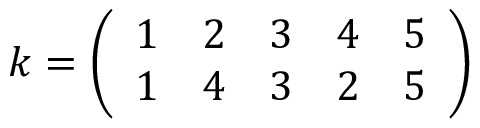Convert formula to latex. <formula><loc_0><loc_0><loc_500><loc_500>k = { \left ( \begin{array} { l l l l l } { 1 } & { 2 } & { 3 } & { 4 } & { 5 } \\ { 1 } & { 4 } & { 3 } & { 2 } & { 5 } \end{array} \right ) }</formula> 